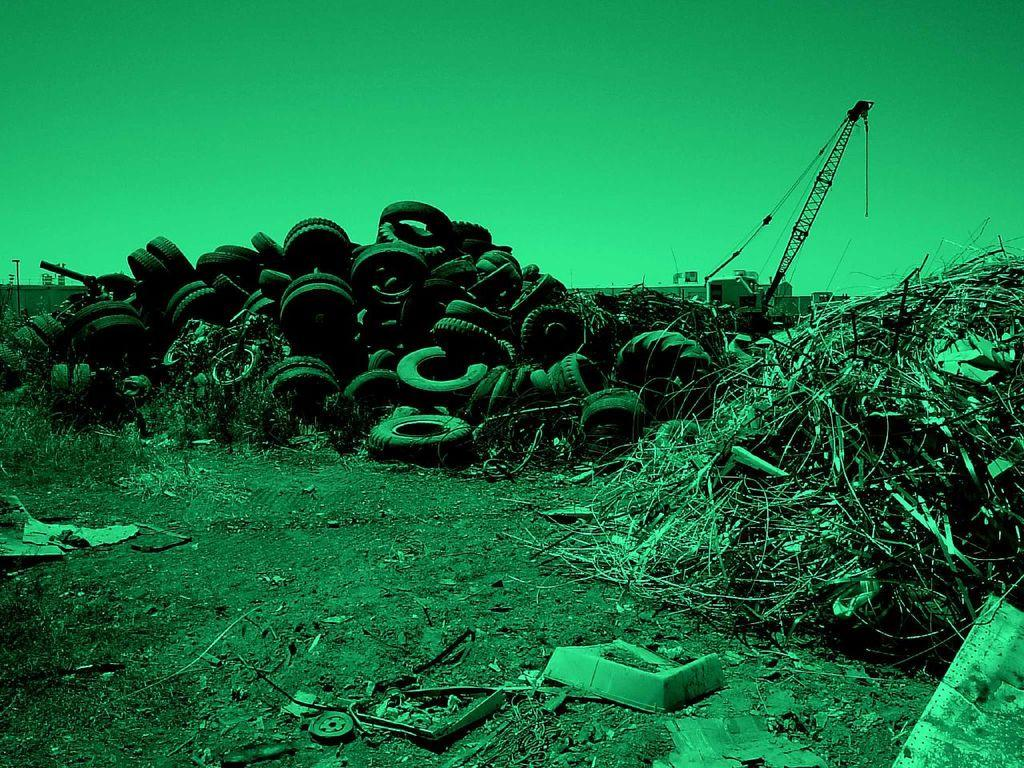What is the main subject of the image? The main subject of the image is many tires. What can be seen on the surface of the tires? There is stuff on the surface of the tires. What type of machinery is visible in the image? There is a crane visible in the image. What is visible in the background of the image? The sky is visible in the image. Where is the stove located in the image? There is no stove present in the image. What type of shock can be seen affecting the tires in the image? There is no shock affecting the tires in the image; they appear to be stationary. 